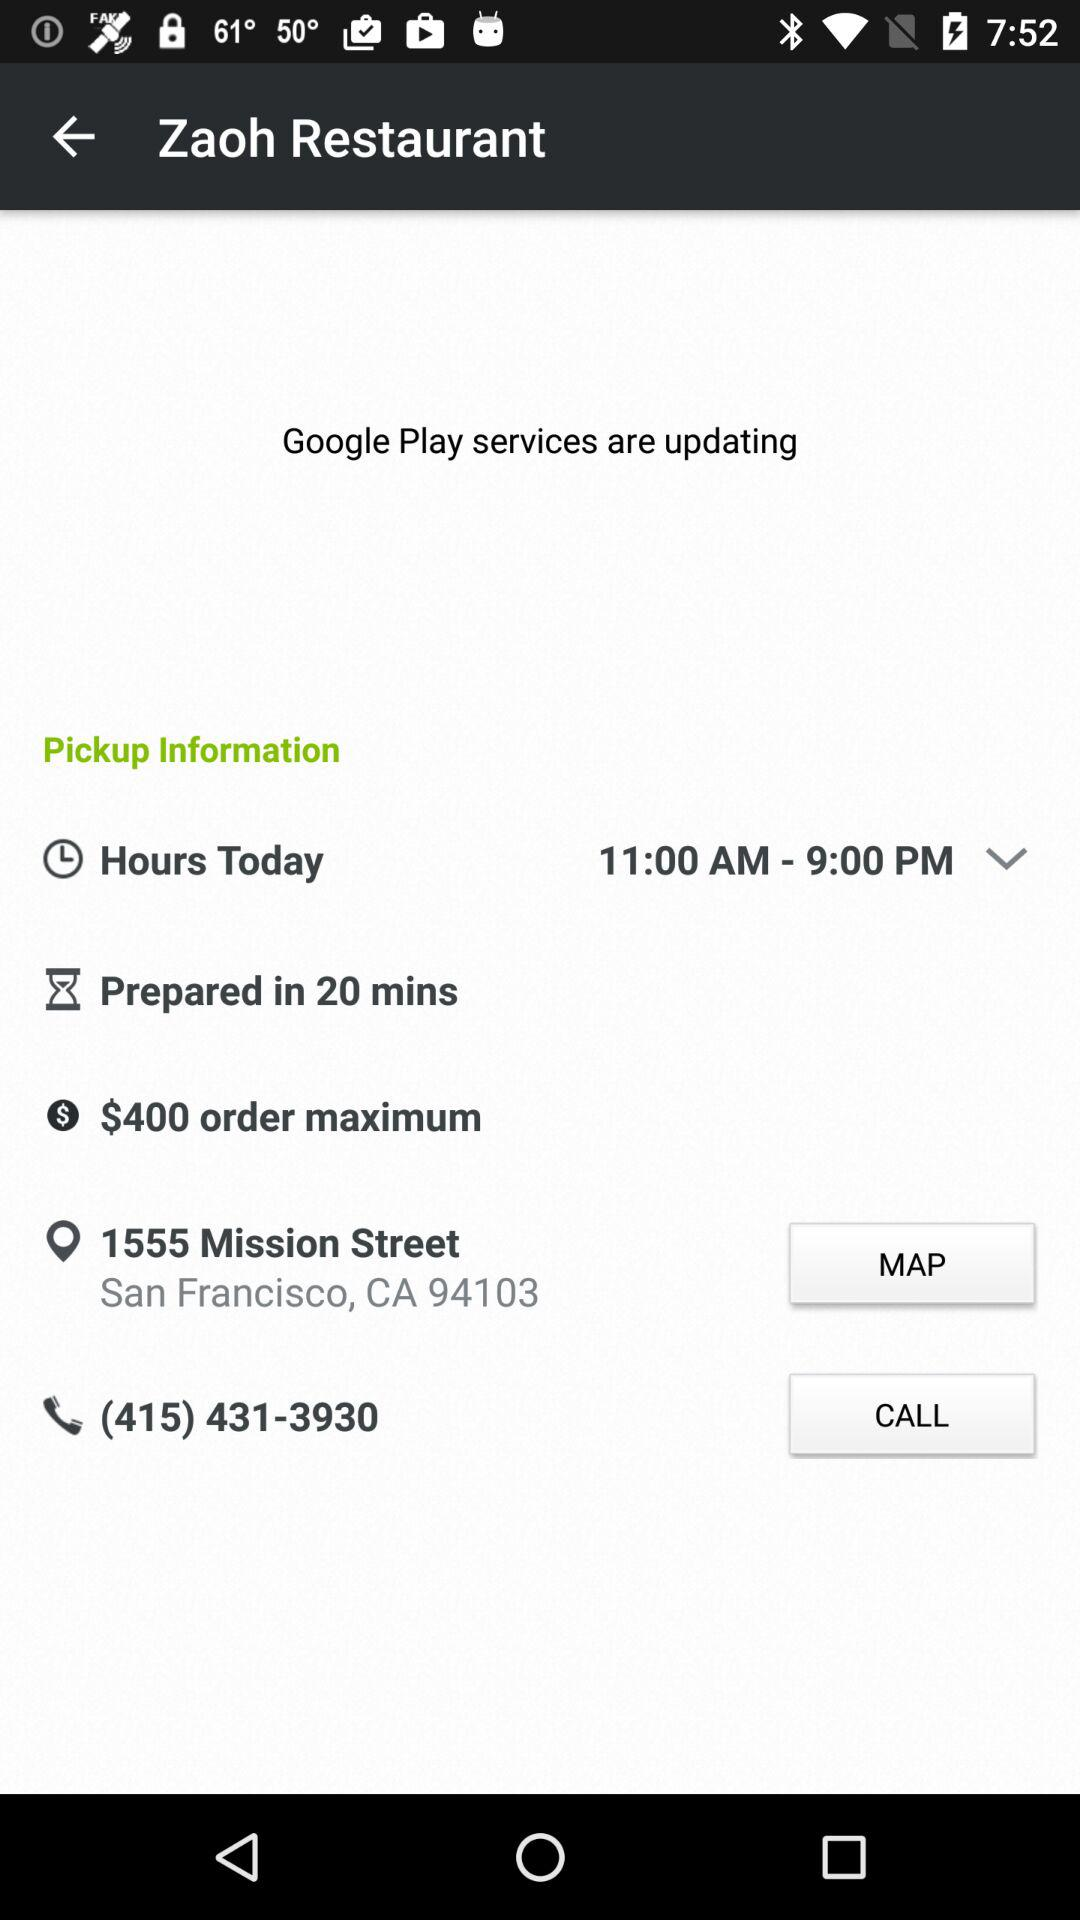What's the contact number? The contact number is (415) 431-3930. 